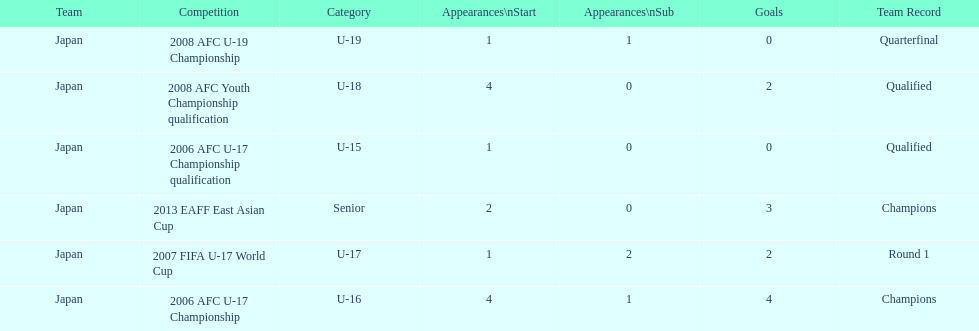How many total goals were scored? 11. 